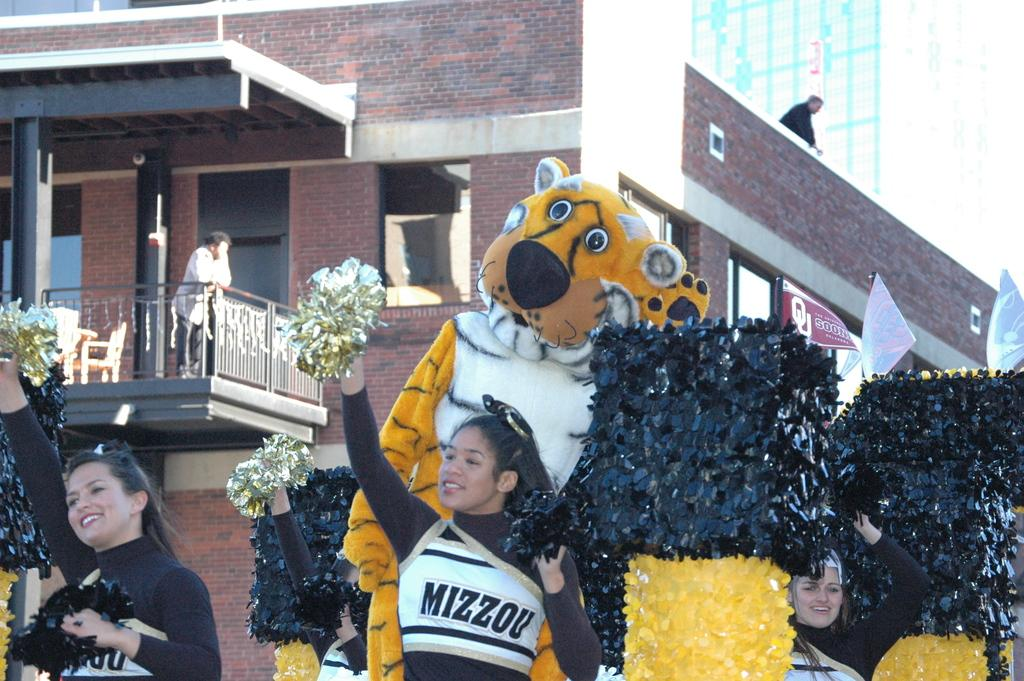<image>
Present a compact description of the photo's key features. Mizzou cheerleaders and mascot participate in a parade. 